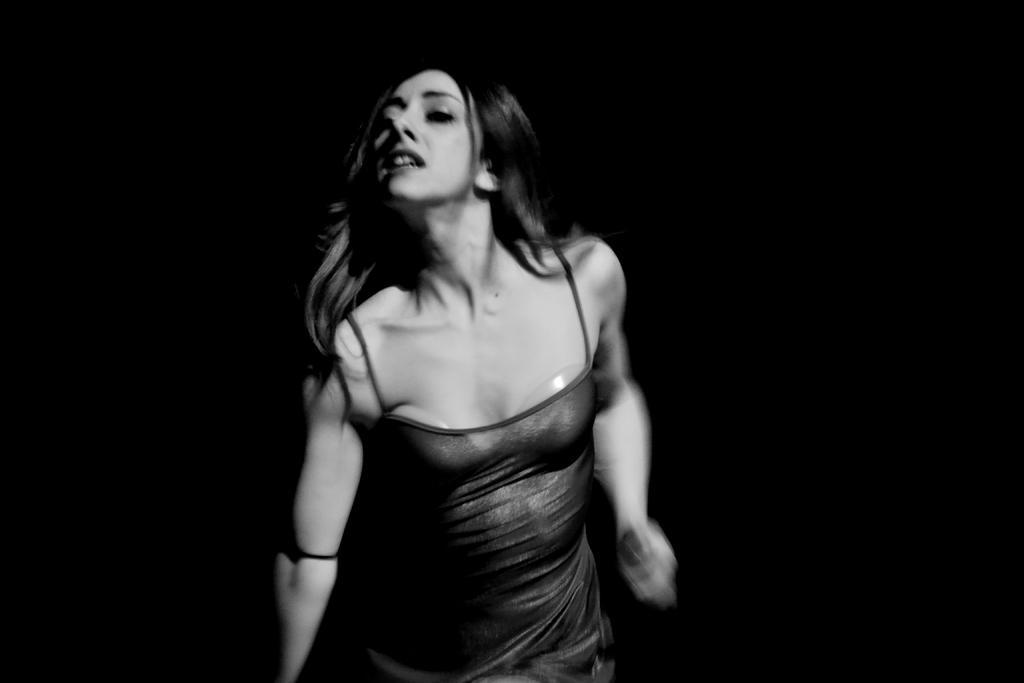In one or two sentences, can you explain what this image depicts? In this image there is a woman,the background is dark. 